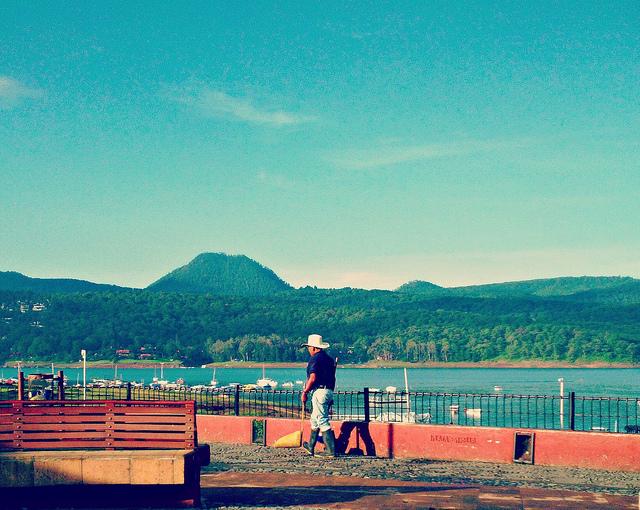What is floating in the water in the background?
Write a very short answer. Boats. Are there any clouds in the sky?
Concise answer only. Yes. What number of bars make up the rack?
Give a very brief answer. 5. What kind of shoes is the man wearing?
Concise answer only. Boots. Is this person wearing a ball cap?
Short answer required. No. What color are the benches?
Keep it brief. Red. 